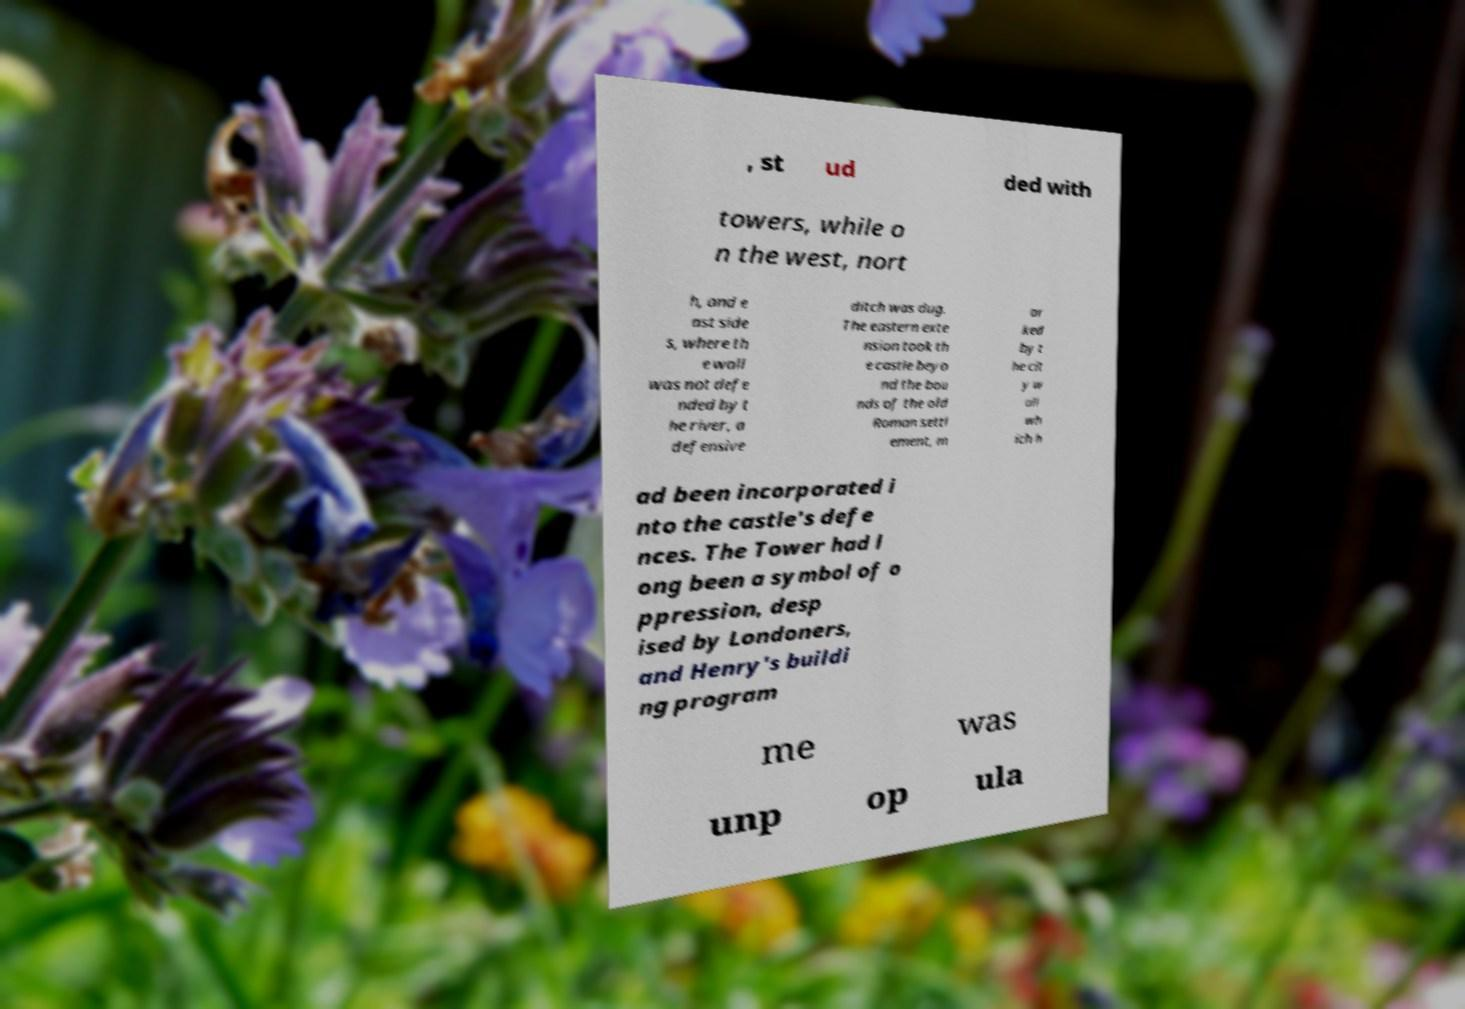There's text embedded in this image that I need extracted. Can you transcribe it verbatim? , st ud ded with towers, while o n the west, nort h, and e ast side s, where th e wall was not defe nded by t he river, a defensive ditch was dug. The eastern exte nsion took th e castle beyo nd the bou nds of the old Roman settl ement, m ar ked by t he cit y w all wh ich h ad been incorporated i nto the castle's defe nces. The Tower had l ong been a symbol of o ppression, desp ised by Londoners, and Henry's buildi ng program me was unp op ula 